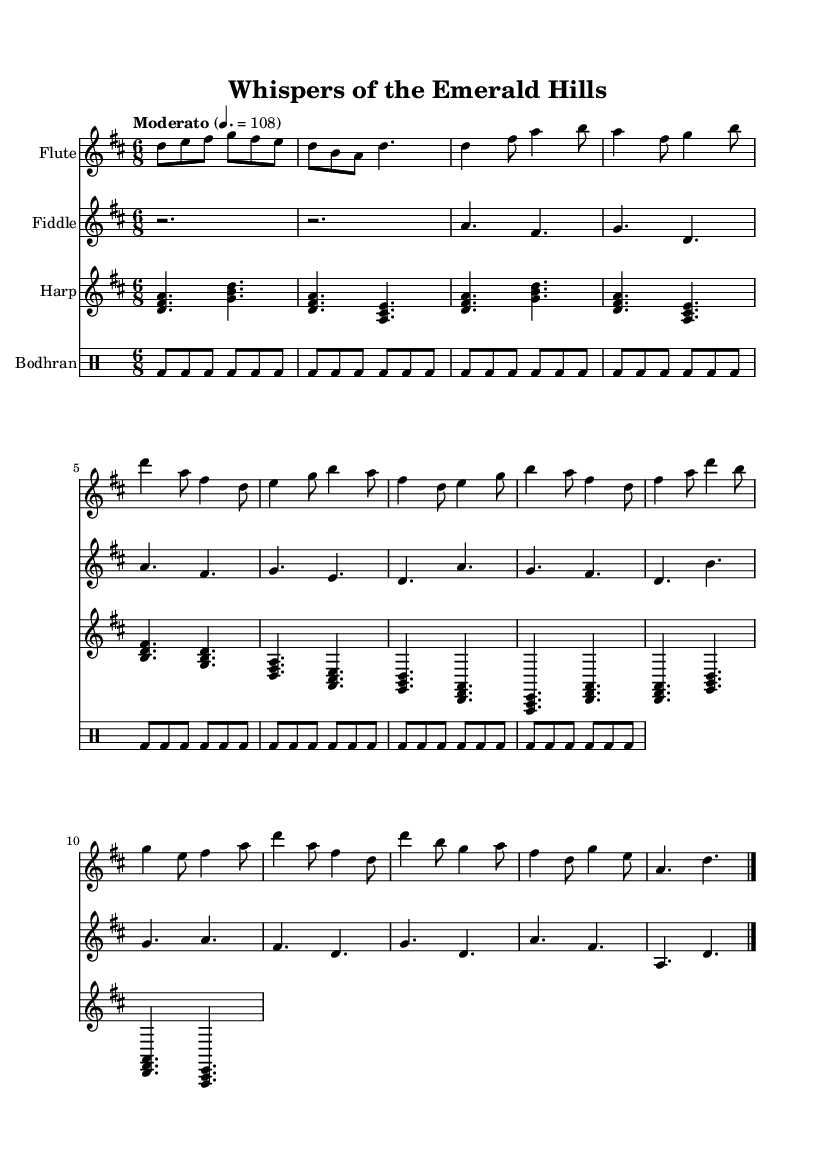What is the key signature of this music? The key signature is indicated at the beginning of the staff, showing two sharps, which are F# and C#. This indicates that the piece is in D major.
Answer: D major What is the time signature of this piece? The time signature can be found at the beginning of the music, displayed as "6/8," which dictates that there are six eighth notes per measure.
Answer: 6/8 What is the tempo marking for this piece? The tempo marking is found near the top of the music, indicating a speed of "Moderato" at a quarter note equaling 108 beats per minute.
Answer: Moderate 108 How many sections are there in the piece? By observing the layout of the music, there are four distinct sections labeled as A, B, C, and a Coda at the end. This indicates a total of four sections.
Answer: Four What instruments are featured in this piece? The instruments are mentioned directly on each staff. They include the flute, fiddle, harp, and bodhran. This shows the instrumentation required for the performance of this piece.
Answer: Flute, fiddle, harp, bodhran Describe the texture of the music. The texture can be inferred from the parts being played. The flute carries the melody, while the fiddle and harp provide harmony and additional melodies, and the bodhran reinforces the rhythm, creating a rich layered texture characteristic of folk music.
Answer: Polyphonic What style of music does this sheet represent? The style can be identified by the traditional elements present, specific instrumentation, and the overall folk feel of the melody and rhythm, which is indicative of Celtic folk music traditions influenced by the natural landscape.
Answer: Traditional Celtic folk music 